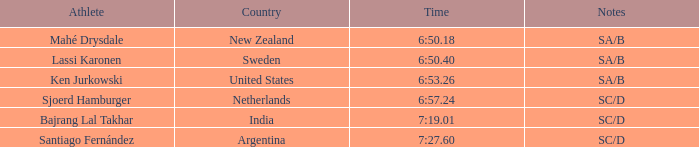Would you mind parsing the complete table? {'header': ['Athlete', 'Country', 'Time', 'Notes'], 'rows': [['Mahé Drysdale', 'New Zealand', '6:50.18', 'SA/B'], ['Lassi Karonen', 'Sweden', '6:50.40', 'SA/B'], ['Ken Jurkowski', 'United States', '6:53.26', 'SA/B'], ['Sjoerd Hamburger', 'Netherlands', '6:57.24', 'SC/D'], ['Bajrang Lal Takhar', 'India', '7:19.01', 'SC/D'], ['Santiago Fernández', 'Argentina', '7:27.60', 'SC/D']]} What is the aggregate of ranks for india? 5.0. 